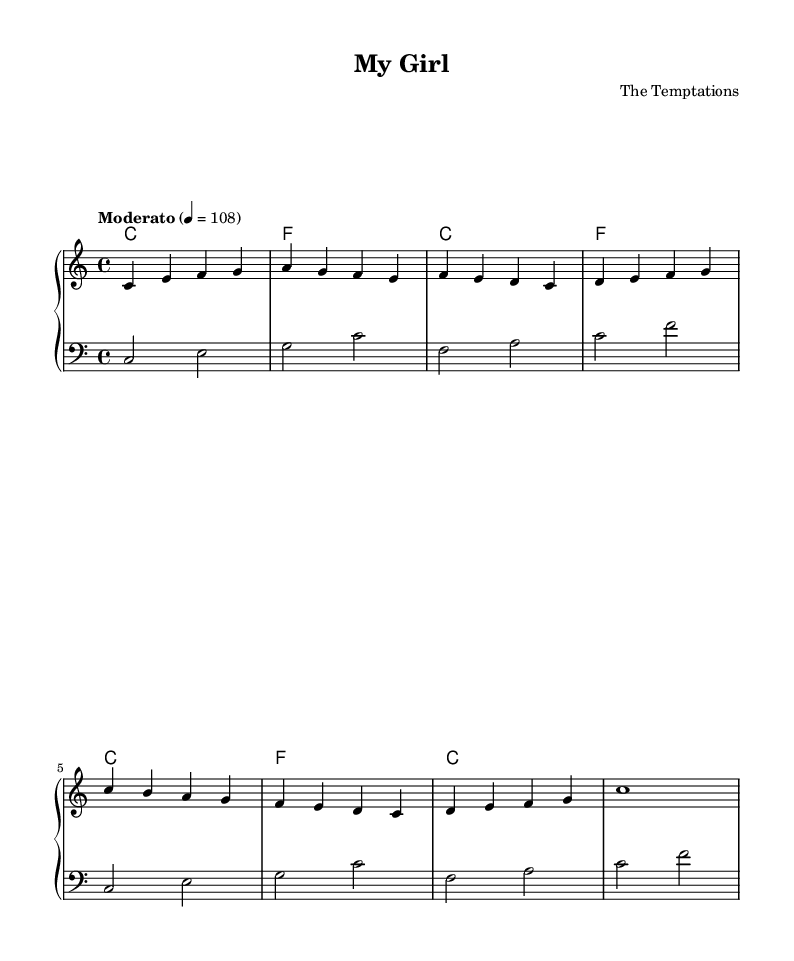What is the title of this piece? The title is indicated at the top of the sheet music, which states "My Girl."
Answer: My Girl What is the key signature of this music? The key signature is C major, which is shown with no sharps or flats on the staff.
Answer: C major What is the time signature of this piece? The time signature is indicated as 4/4, which means there are four beats in each measure.
Answer: 4/4 What is the indicated tempo for this music? The tempo marking states "Moderato" with a metronome marking of 108, indicating a moderate speed.
Answer: Moderato Which instruments are arranged in the score? The score is arranged for piano, consisting of two staffs: one for the right hand and one for the left hand.
Answer: Piano How many measures are shown in the melody? By counting the segments in the melody section, there are 8 measures displayed in total.
Answer: 8 What is the genre of this piece? Based on the title and historical context, this piece is classified as a classic Motown soul hit.
Answer: Soul 